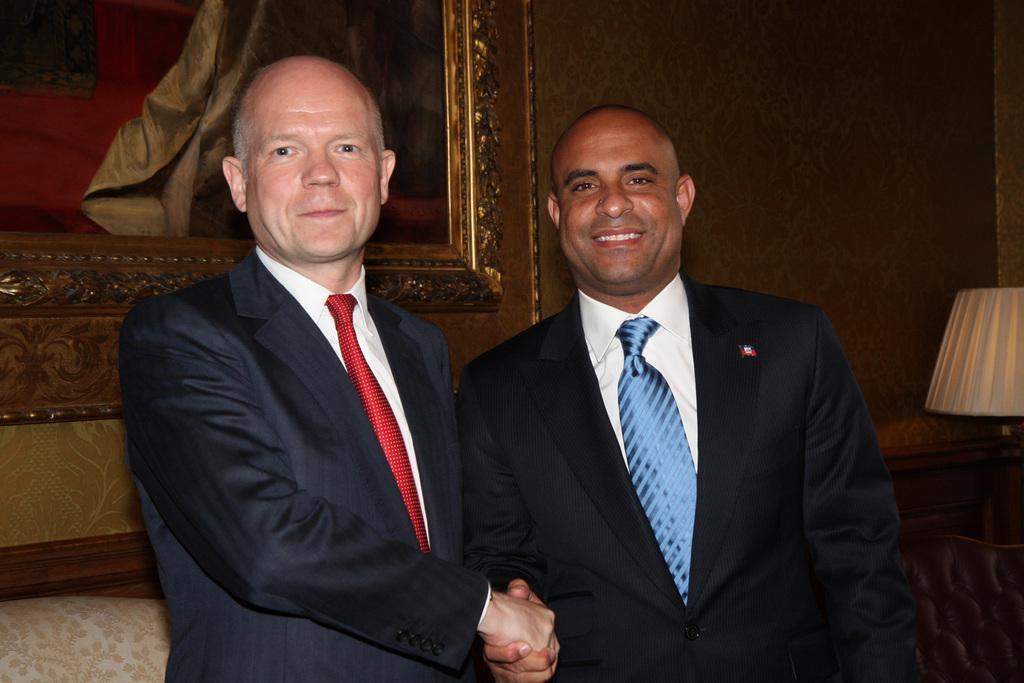Can you describe this image briefly? In the picture there are two men, they are holding each other's hands and posing for the photo. In the background there is a wall and in front of the wall there is a frame. On the right side there is a lamp. 